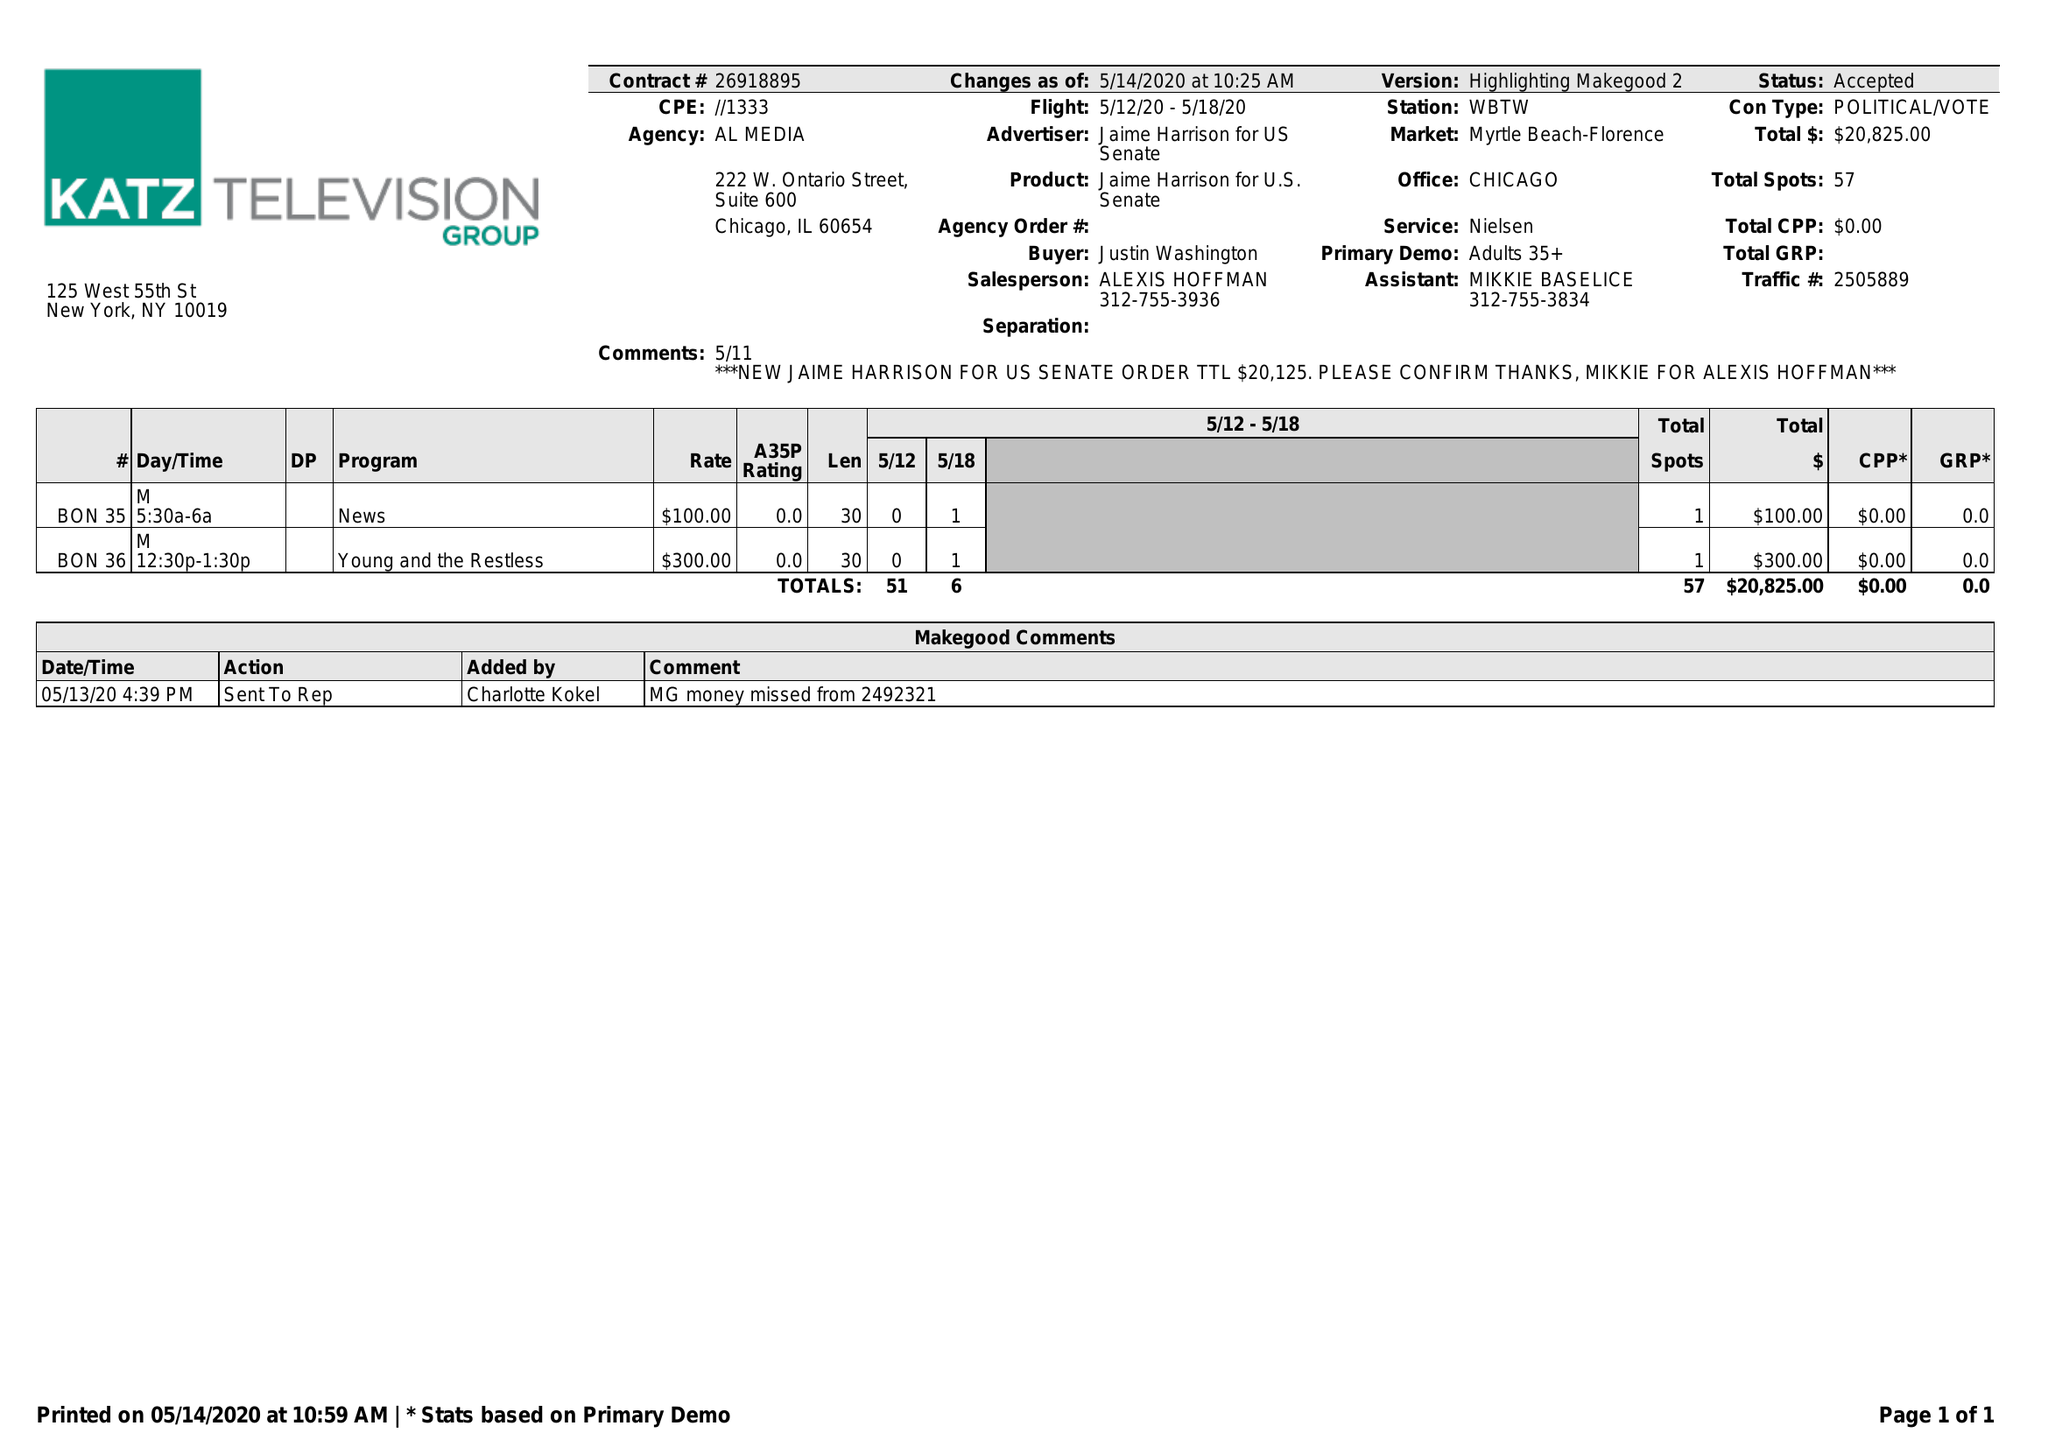What is the value for the advertiser?
Answer the question using a single word or phrase. JAIME HARRISON FOR US SENATE 